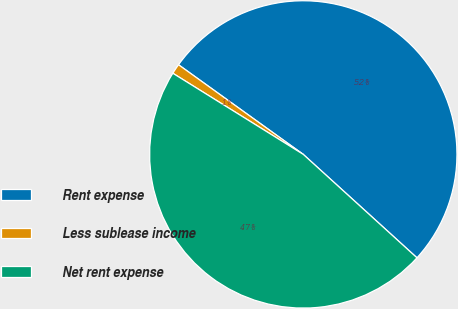<chart> <loc_0><loc_0><loc_500><loc_500><pie_chart><fcel>Rent expense<fcel>Less sublease income<fcel>Net rent expense<nl><fcel>51.83%<fcel>1.06%<fcel>47.11%<nl></chart> 